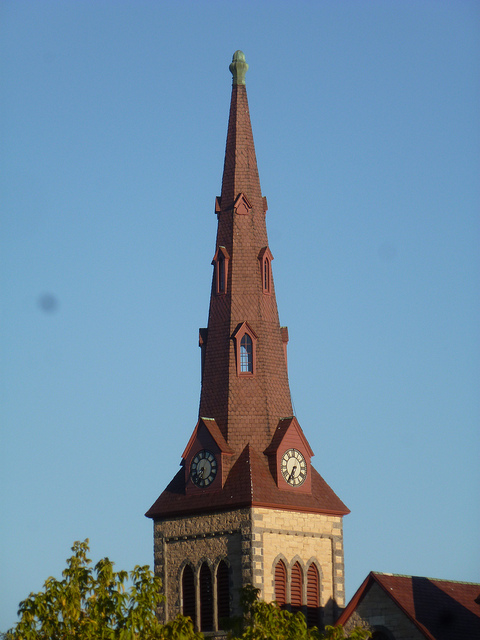<image>What country is this clock located in? It is unknown what country the clock is located in. It could be in England, Germany, or France. What country is this clock located in? I don't know which country this clock is located in. It can be England, Germany, London, or France. 